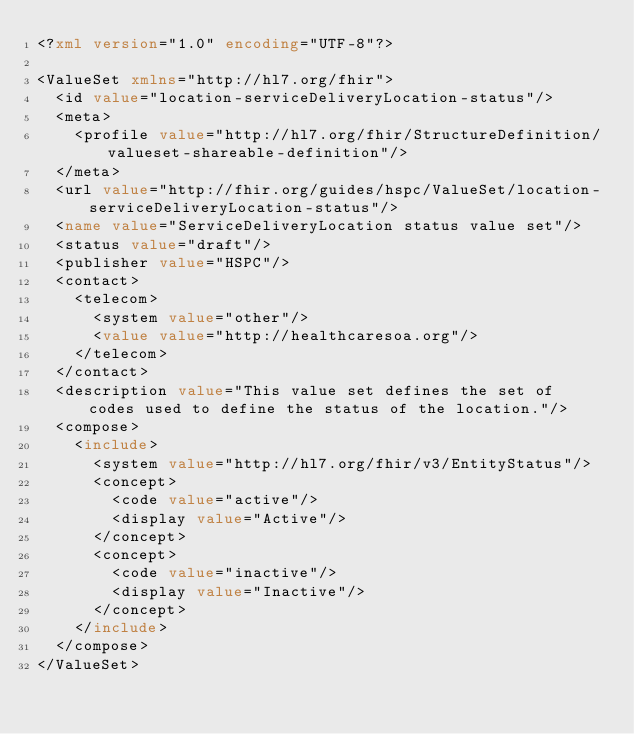Convert code to text. <code><loc_0><loc_0><loc_500><loc_500><_XML_><?xml version="1.0" encoding="UTF-8"?>

<ValueSet xmlns="http://hl7.org/fhir">
  <id value="location-serviceDeliveryLocation-status"/>
  <meta>
    <profile value="http://hl7.org/fhir/StructureDefinition/valueset-shareable-definition"/>
  </meta>
  <url value="http://fhir.org/guides/hspc/ValueSet/location-serviceDeliveryLocation-status"/>
  <name value="ServiceDeliveryLocation status value set"/>
  <status value="draft"/>
  <publisher value="HSPC"/>
  <contact>
    <telecom>
      <system value="other"/>
      <value value="http://healthcaresoa.org"/>
    </telecom>
  </contact>
  <description value="This value set defines the set of codes used to define the status of the location."/>
  <compose>
    <include>
      <system value="http://hl7.org/fhir/v3/EntityStatus"/>
      <concept>
        <code value="active"/>
        <display value="Active"/>
      </concept>
      <concept>
        <code value="inactive"/>
        <display value="Inactive"/>
      </concept>
    </include>
  </compose>
</ValueSet></code> 